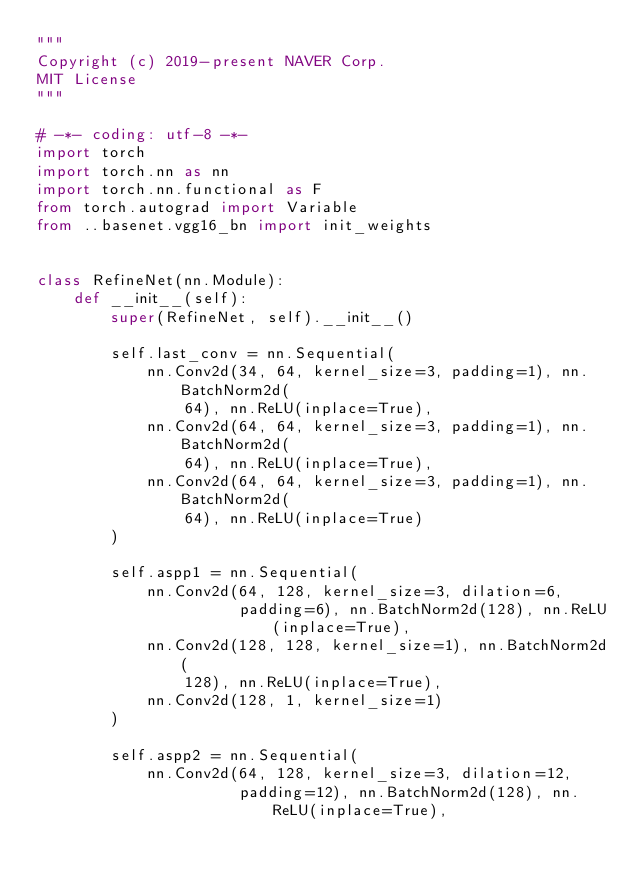Convert code to text. <code><loc_0><loc_0><loc_500><loc_500><_Python_>"""
Copyright (c) 2019-present NAVER Corp.
MIT License
"""

# -*- coding: utf-8 -*-
import torch
import torch.nn as nn
import torch.nn.functional as F
from torch.autograd import Variable
from ..basenet.vgg16_bn import init_weights


class RefineNet(nn.Module):
    def __init__(self):
        super(RefineNet, self).__init__()

        self.last_conv = nn.Sequential(
            nn.Conv2d(34, 64, kernel_size=3, padding=1), nn.BatchNorm2d(
                64), nn.ReLU(inplace=True),
            nn.Conv2d(64, 64, kernel_size=3, padding=1), nn.BatchNorm2d(
                64), nn.ReLU(inplace=True),
            nn.Conv2d(64, 64, kernel_size=3, padding=1), nn.BatchNorm2d(
                64), nn.ReLU(inplace=True)
        )

        self.aspp1 = nn.Sequential(
            nn.Conv2d(64, 128, kernel_size=3, dilation=6,
                      padding=6), nn.BatchNorm2d(128), nn.ReLU(inplace=True),
            nn.Conv2d(128, 128, kernel_size=1), nn.BatchNorm2d(
                128), nn.ReLU(inplace=True),
            nn.Conv2d(128, 1, kernel_size=1)
        )

        self.aspp2 = nn.Sequential(
            nn.Conv2d(64, 128, kernel_size=3, dilation=12,
                      padding=12), nn.BatchNorm2d(128), nn.ReLU(inplace=True),</code> 